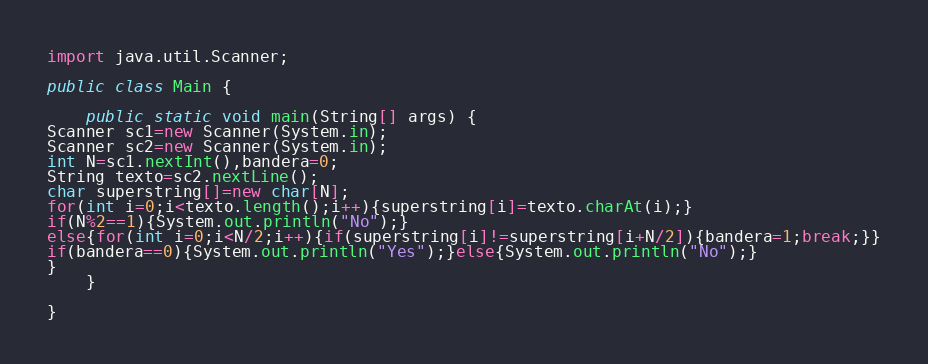Convert code to text. <code><loc_0><loc_0><loc_500><loc_500><_Java_>

import java.util.Scanner;

public class Main {

    public static void main(String[] args) {
Scanner sc1=new Scanner(System.in);
Scanner sc2=new Scanner(System.in);
int N=sc1.nextInt(),bandera=0;
String texto=sc2.nextLine();
char superstring[]=new char[N];
for(int i=0;i<texto.length();i++){superstring[i]=texto.charAt(i);}
if(N%2==1){System.out.println("No");}
else{for(int i=0;i<N/2;i++){if(superstring[i]!=superstring[i+N/2]){bandera=1;break;}}
if(bandera==0){System.out.println("Yes");}else{System.out.println("No");}
}
    }
    
}</code> 